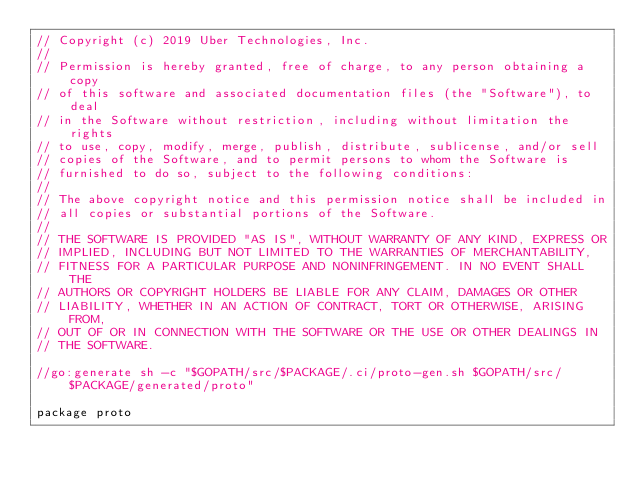Convert code to text. <code><loc_0><loc_0><loc_500><loc_500><_Go_>// Copyright (c) 2019 Uber Technologies, Inc.
//
// Permission is hereby granted, free of charge, to any person obtaining a copy
// of this software and associated documentation files (the "Software"), to deal
// in the Software without restriction, including without limitation the rights
// to use, copy, modify, merge, publish, distribute, sublicense, and/or sell
// copies of the Software, and to permit persons to whom the Software is
// furnished to do so, subject to the following conditions:
//
// The above copyright notice and this permission notice shall be included in
// all copies or substantial portions of the Software.
//
// THE SOFTWARE IS PROVIDED "AS IS", WITHOUT WARRANTY OF ANY KIND, EXPRESS OR
// IMPLIED, INCLUDING BUT NOT LIMITED TO THE WARRANTIES OF MERCHANTABILITY,
// FITNESS FOR A PARTICULAR PURPOSE AND NONINFRINGEMENT. IN NO EVENT SHALL THE
// AUTHORS OR COPYRIGHT HOLDERS BE LIABLE FOR ANY CLAIM, DAMAGES OR OTHER
// LIABILITY, WHETHER IN AN ACTION OF CONTRACT, TORT OR OTHERWISE, ARISING FROM,
// OUT OF OR IN CONNECTION WITH THE SOFTWARE OR THE USE OR OTHER DEALINGS IN
// THE SOFTWARE.

//go:generate sh -c "$GOPATH/src/$PACKAGE/.ci/proto-gen.sh $GOPATH/src/$PACKAGE/generated/proto"

package proto
</code> 